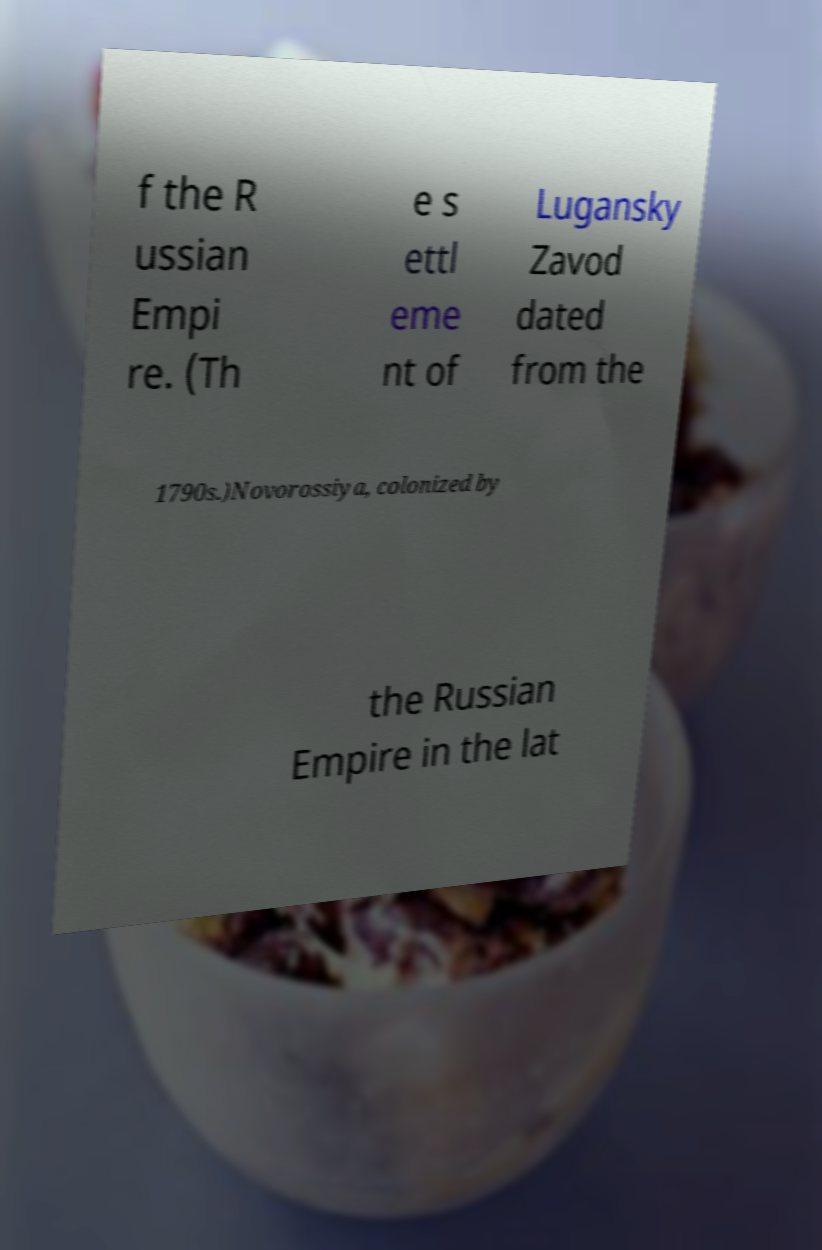Could you assist in decoding the text presented in this image and type it out clearly? f the R ussian Empi re. (Th e s ettl eme nt of Lugansky Zavod dated from the 1790s.)Novorossiya, colonized by the Russian Empire in the lat 